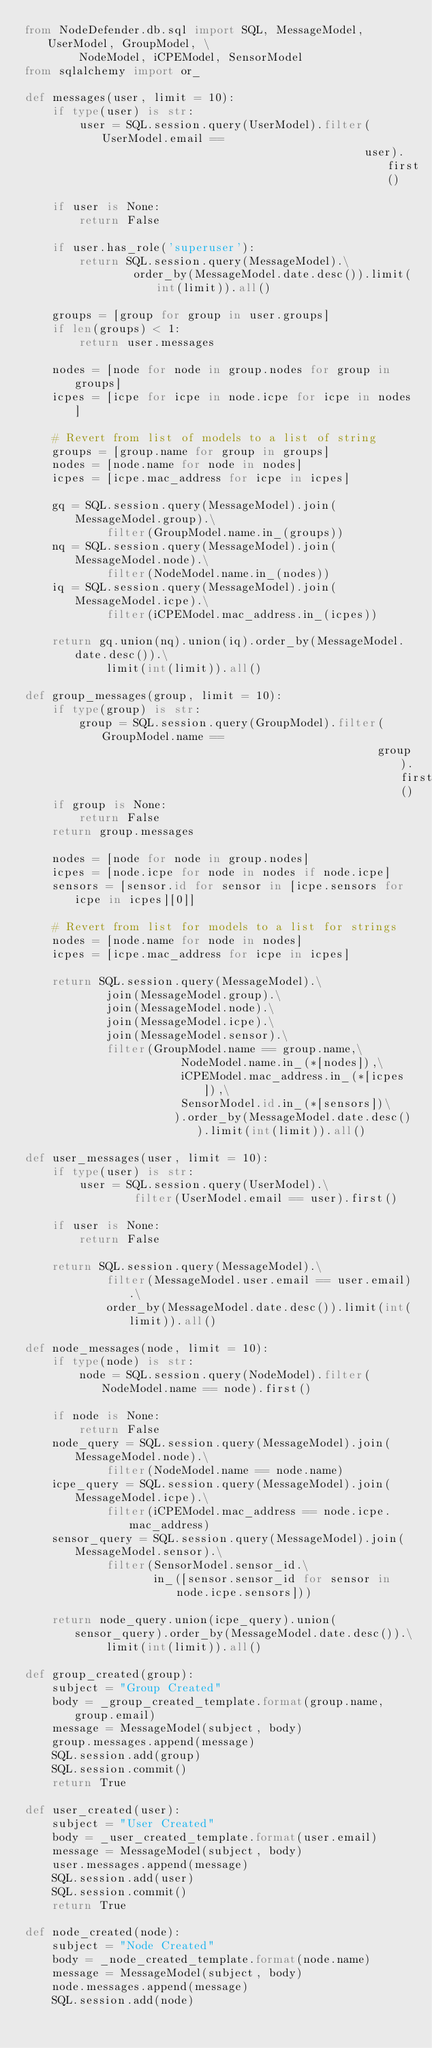<code> <loc_0><loc_0><loc_500><loc_500><_Python_>from NodeDefender.db.sql import SQL, MessageModel, UserModel, GroupModel, \
        NodeModel, iCPEModel, SensorModel
from sqlalchemy import or_

def messages(user, limit = 10):
    if type(user) is str:
        user = SQL.session.query(UserModel).filter(UserModel.email ==
                                                  user).first()
    
    if user is None:
        return False

    if user.has_role('superuser'):
        return SQL.session.query(MessageModel).\
                order_by(MessageModel.date.desc()).limit(int(limit)).all()
     
    groups = [group for group in user.groups]
    if len(groups) < 1:
        return user.messages
    
    nodes = [node for node in group.nodes for group in groups]
    icpes = [icpe for icpe in node.icpe for icpe in nodes]

    # Revert from list of models to a list of string
    groups = [group.name for group in groups]
    nodes = [node.name for node in nodes]
    icpes = [icpe.mac_address for icpe in icpes]

    gq = SQL.session.query(MessageModel).join(MessageModel.group).\
            filter(GroupModel.name.in_(groups))
    nq = SQL.session.query(MessageModel).join(MessageModel.node).\
            filter(NodeModel.name.in_(nodes))
    iq = SQL.session.query(MessageModel).join(MessageModel.icpe).\
            filter(iCPEModel.mac_address.in_(icpes))

    return gq.union(nq).union(iq).order_by(MessageModel.date.desc()).\
            limit(int(limit)).all()

def group_messages(group, limit = 10):
    if type(group) is str:
        group = SQL.session.query(GroupModel).filter(GroupModel.name ==
                                                    group).first()
    if group is None:
        return False
    return group.messages

    nodes = [node for node in group.nodes]
    icpes = [node.icpe for node in nodes if node.icpe]
    sensors = [sensor.id for sensor in [icpe.sensors for icpe in icpes][0]]

    # Revert from list for models to a list for strings
    nodes = [node.name for node in nodes]
    icpes = [icpe.mac_address for icpe in icpes]

    return SQL.session.query(MessageModel).\
            join(MessageModel.group).\
            join(MessageModel.node).\
            join(MessageModel.icpe).\
            join(MessageModel.sensor).\
            filter(GroupModel.name == group.name,\
                       NodeModel.name.in_(*[nodes]),\
                       iCPEModel.mac_address.in_(*[icpes]),\
                       SensorModel.id.in_(*[sensors])\
                      ).order_by(MessageModel.date.desc()).limit(int(limit)).all()

def user_messages(user, limit = 10):
    if type(user) is str:
        user = SQL.session.query(UserModel).\
                filter(UserModel.email == user).first()

    if user is None:
        return False

    return SQL.session.query(MessageModel).\
            filter(MessageModel.user.email == user.email).\
            order_by(MessageModel.date.desc()).limit(int(limit)).all()

def node_messages(node, limit = 10):
    if type(node) is str:
        node = SQL.session.query(NodeModel).filter(NodeModel.name == node).first()

    if node is None:
        return False
    node_query = SQL.session.query(MessageModel).join(MessageModel.node).\
            filter(NodeModel.name == node.name)
    icpe_query = SQL.session.query(MessageModel).join(MessageModel.icpe).\
            filter(iCPEModel.mac_address == node.icpe.mac_address)
    sensor_query = SQL.session.query(MessageModel).join(MessageModel.sensor).\
            filter(SensorModel.sensor_id.\
                   in_([sensor.sensor_id for sensor in node.icpe.sensors]))
    
    return node_query.union(icpe_query).union(sensor_query).order_by(MessageModel.date.desc()).\
            limit(int(limit)).all()

def group_created(group):
    subject = "Group Created"
    body = _group_created_template.format(group.name, group.email)
    message = MessageModel(subject, body)
    group.messages.append(message)
    SQL.session.add(group)
    SQL.session.commit()
    return True

def user_created(user):
    subject = "User Created"
    body = _user_created_template.format(user.email)
    message = MessageModel(subject, body)
    user.messages.append(message)
    SQL.session.add(user)
    SQL.session.commit()
    return True

def node_created(node):
    subject = "Node Created"
    body = _node_created_template.format(node.name)
    message = MessageModel(subject, body)
    node.messages.append(message)
    SQL.session.add(node)</code> 